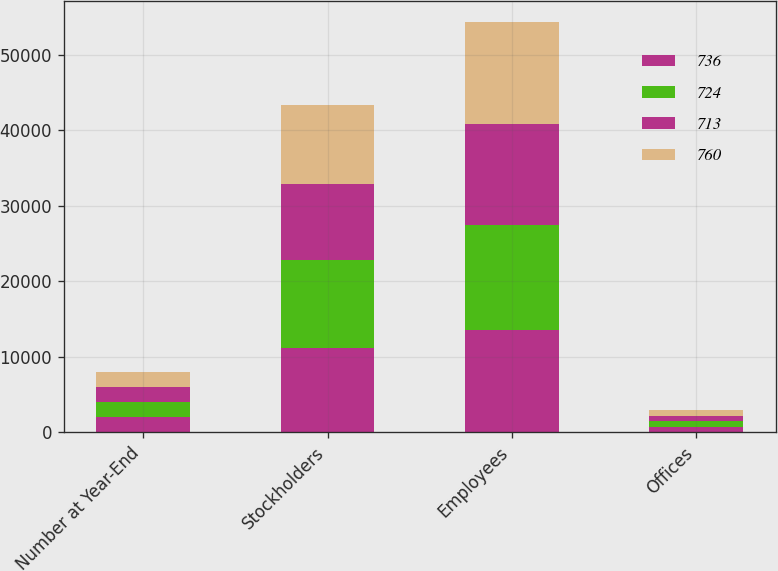<chart> <loc_0><loc_0><loc_500><loc_500><stacked_bar_chart><ecel><fcel>Number at Year-End<fcel>Stockholders<fcel>Employees<fcel>Offices<nl><fcel>736<fcel>2008<fcel>11197<fcel>13620<fcel>725<nl><fcel>724<fcel>2007<fcel>11611<fcel>13869<fcel>760<nl><fcel>713<fcel>2006<fcel>10084<fcel>13352<fcel>736<nl><fcel>760<fcel>2005<fcel>10437<fcel>13525<fcel>724<nl></chart> 